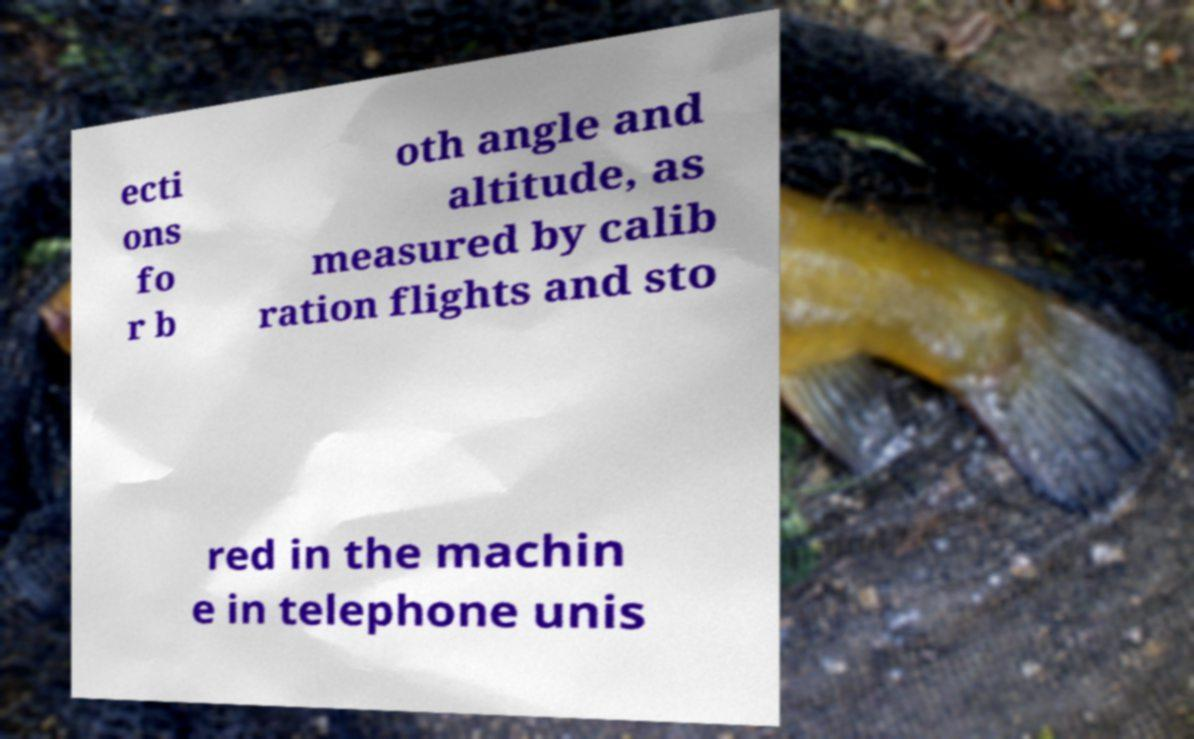Can you read and provide the text displayed in the image?This photo seems to have some interesting text. Can you extract and type it out for me? ecti ons fo r b oth angle and altitude, as measured by calib ration flights and sto red in the machin e in telephone unis 